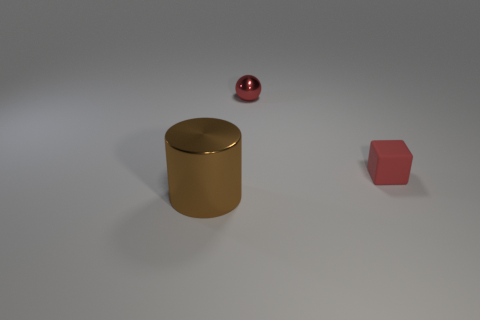There is a metallic object that is behind the brown shiny object; how many cylinders are on the left side of it?
Your answer should be very brief. 1. How many balls are purple objects or metallic things?
Provide a succinct answer. 1. Are any big gray rubber cubes visible?
Provide a short and direct response. No. There is a shiny thing on the left side of the metallic object on the right side of the large object; what is its shape?
Offer a terse response. Cylinder. What number of brown objects are either metallic cubes or large metal objects?
Offer a very short reply. 1. The large cylinder has what color?
Offer a very short reply. Brown. Do the brown thing and the red metallic ball have the same size?
Your answer should be compact. No. Is there any other thing that is the same shape as the large shiny object?
Give a very brief answer. No. Is the material of the large thing the same as the thing to the right of the red metal sphere?
Make the answer very short. No. Does the metal thing on the left side of the small red metallic ball have the same color as the tiny matte object?
Offer a terse response. No. 